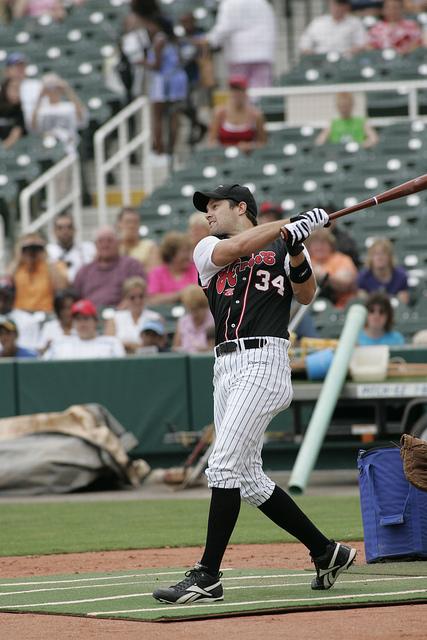Are the stands full?
Quick response, please. No. Where is the bat?
Answer briefly. In his hands. What is the number of this players Jersey?
Write a very short answer. 34. What is the number on the jersey?
Quick response, please. 34. What color are the man's socks?
Write a very short answer. Black. 